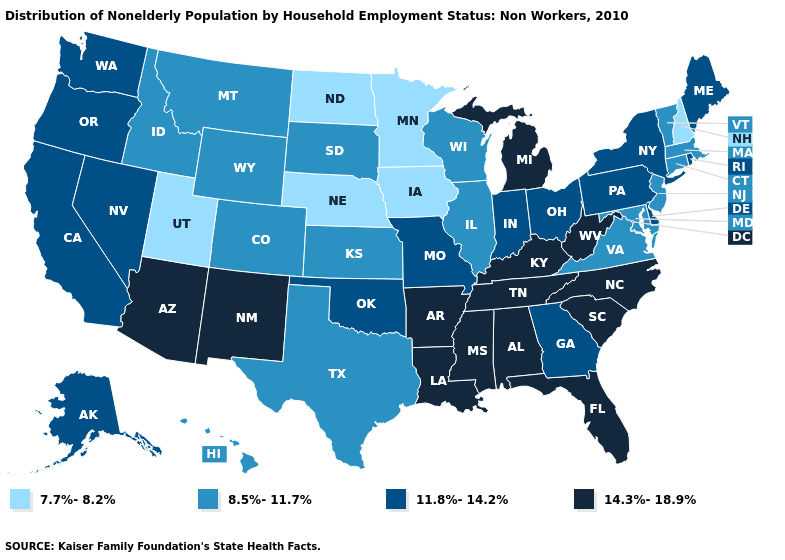How many symbols are there in the legend?
Concise answer only. 4. Is the legend a continuous bar?
Give a very brief answer. No. Among the states that border Missouri , does Kansas have the highest value?
Short answer required. No. Does the map have missing data?
Give a very brief answer. No. Which states have the lowest value in the USA?
Answer briefly. Iowa, Minnesota, Nebraska, New Hampshire, North Dakota, Utah. Which states have the highest value in the USA?
Short answer required. Alabama, Arizona, Arkansas, Florida, Kentucky, Louisiana, Michigan, Mississippi, New Mexico, North Carolina, South Carolina, Tennessee, West Virginia. Name the states that have a value in the range 14.3%-18.9%?
Give a very brief answer. Alabama, Arizona, Arkansas, Florida, Kentucky, Louisiana, Michigan, Mississippi, New Mexico, North Carolina, South Carolina, Tennessee, West Virginia. What is the value of Louisiana?
Short answer required. 14.3%-18.9%. Name the states that have a value in the range 11.8%-14.2%?
Keep it brief. Alaska, California, Delaware, Georgia, Indiana, Maine, Missouri, Nevada, New York, Ohio, Oklahoma, Oregon, Pennsylvania, Rhode Island, Washington. Does Iowa have the lowest value in the USA?
Give a very brief answer. Yes. Which states have the highest value in the USA?
Quick response, please. Alabama, Arizona, Arkansas, Florida, Kentucky, Louisiana, Michigan, Mississippi, New Mexico, North Carolina, South Carolina, Tennessee, West Virginia. Among the states that border Louisiana , does Mississippi have the lowest value?
Write a very short answer. No. Name the states that have a value in the range 11.8%-14.2%?
Short answer required. Alaska, California, Delaware, Georgia, Indiana, Maine, Missouri, Nevada, New York, Ohio, Oklahoma, Oregon, Pennsylvania, Rhode Island, Washington. Which states have the lowest value in the South?
Write a very short answer. Maryland, Texas, Virginia. Name the states that have a value in the range 14.3%-18.9%?
Answer briefly. Alabama, Arizona, Arkansas, Florida, Kentucky, Louisiana, Michigan, Mississippi, New Mexico, North Carolina, South Carolina, Tennessee, West Virginia. 